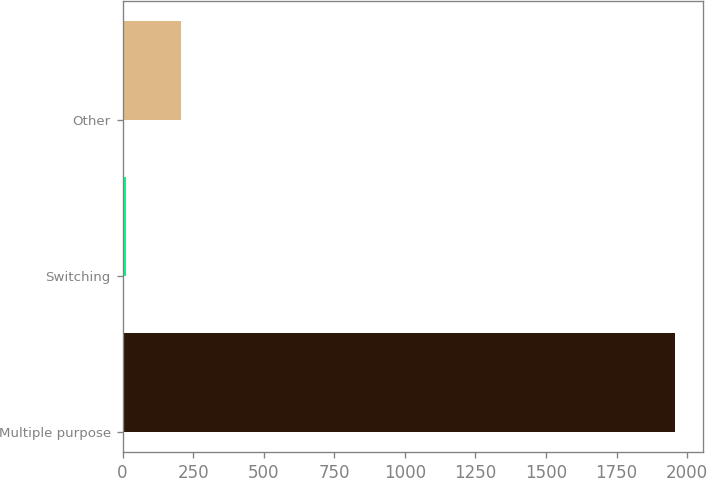Convert chart to OTSL. <chart><loc_0><loc_0><loc_500><loc_500><bar_chart><fcel>Multiple purpose<fcel>Switching<fcel>Other<nl><fcel>1958<fcel>12<fcel>206.6<nl></chart> 